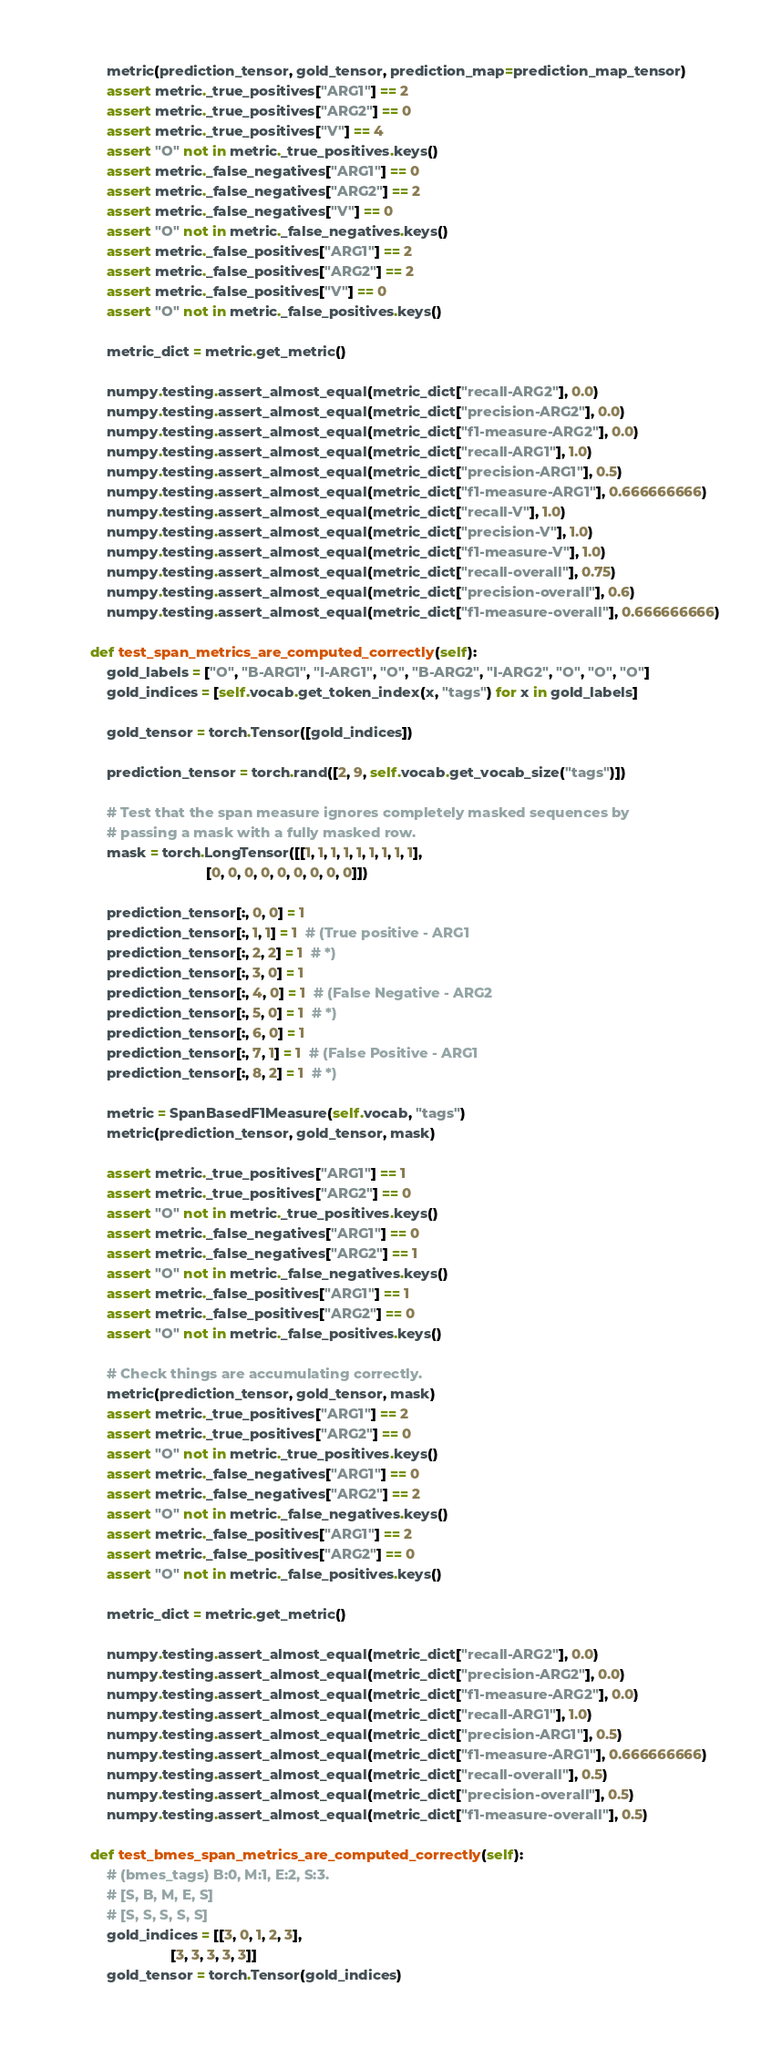Convert code to text. <code><loc_0><loc_0><loc_500><loc_500><_Python_>        metric(prediction_tensor, gold_tensor, prediction_map=prediction_map_tensor)
        assert metric._true_positives["ARG1"] == 2
        assert metric._true_positives["ARG2"] == 0
        assert metric._true_positives["V"] == 4
        assert "O" not in metric._true_positives.keys()
        assert metric._false_negatives["ARG1"] == 0
        assert metric._false_negatives["ARG2"] == 2
        assert metric._false_negatives["V"] == 0
        assert "O" not in metric._false_negatives.keys()
        assert metric._false_positives["ARG1"] == 2
        assert metric._false_positives["ARG2"] == 2
        assert metric._false_positives["V"] == 0
        assert "O" not in metric._false_positives.keys()

        metric_dict = metric.get_metric()

        numpy.testing.assert_almost_equal(metric_dict["recall-ARG2"], 0.0)
        numpy.testing.assert_almost_equal(metric_dict["precision-ARG2"], 0.0)
        numpy.testing.assert_almost_equal(metric_dict["f1-measure-ARG2"], 0.0)
        numpy.testing.assert_almost_equal(metric_dict["recall-ARG1"], 1.0)
        numpy.testing.assert_almost_equal(metric_dict["precision-ARG1"], 0.5)
        numpy.testing.assert_almost_equal(metric_dict["f1-measure-ARG1"], 0.666666666)
        numpy.testing.assert_almost_equal(metric_dict["recall-V"], 1.0)
        numpy.testing.assert_almost_equal(metric_dict["precision-V"], 1.0)
        numpy.testing.assert_almost_equal(metric_dict["f1-measure-V"], 1.0)
        numpy.testing.assert_almost_equal(metric_dict["recall-overall"], 0.75)
        numpy.testing.assert_almost_equal(metric_dict["precision-overall"], 0.6)
        numpy.testing.assert_almost_equal(metric_dict["f1-measure-overall"], 0.666666666)

    def test_span_metrics_are_computed_correctly(self):
        gold_labels = ["O", "B-ARG1", "I-ARG1", "O", "B-ARG2", "I-ARG2", "O", "O", "O"]
        gold_indices = [self.vocab.get_token_index(x, "tags") for x in gold_labels]

        gold_tensor = torch.Tensor([gold_indices])

        prediction_tensor = torch.rand([2, 9, self.vocab.get_vocab_size("tags")])

        # Test that the span measure ignores completely masked sequences by
        # passing a mask with a fully masked row.
        mask = torch.LongTensor([[1, 1, 1, 1, 1, 1, 1, 1, 1],
                                 [0, 0, 0, 0, 0, 0, 0, 0, 0]])

        prediction_tensor[:, 0, 0] = 1
        prediction_tensor[:, 1, 1] = 1  # (True positive - ARG1
        prediction_tensor[:, 2, 2] = 1  # *)
        prediction_tensor[:, 3, 0] = 1
        prediction_tensor[:, 4, 0] = 1  # (False Negative - ARG2
        prediction_tensor[:, 5, 0] = 1  # *)
        prediction_tensor[:, 6, 0] = 1
        prediction_tensor[:, 7, 1] = 1  # (False Positive - ARG1
        prediction_tensor[:, 8, 2] = 1  # *)

        metric = SpanBasedF1Measure(self.vocab, "tags")
        metric(prediction_tensor, gold_tensor, mask)

        assert metric._true_positives["ARG1"] == 1
        assert metric._true_positives["ARG2"] == 0
        assert "O" not in metric._true_positives.keys()
        assert metric._false_negatives["ARG1"] == 0
        assert metric._false_negatives["ARG2"] == 1
        assert "O" not in metric._false_negatives.keys()
        assert metric._false_positives["ARG1"] == 1
        assert metric._false_positives["ARG2"] == 0
        assert "O" not in metric._false_positives.keys()

        # Check things are accumulating correctly.
        metric(prediction_tensor, gold_tensor, mask)
        assert metric._true_positives["ARG1"] == 2
        assert metric._true_positives["ARG2"] == 0
        assert "O" not in metric._true_positives.keys()
        assert metric._false_negatives["ARG1"] == 0
        assert metric._false_negatives["ARG2"] == 2
        assert "O" not in metric._false_negatives.keys()
        assert metric._false_positives["ARG1"] == 2
        assert metric._false_positives["ARG2"] == 0
        assert "O" not in metric._false_positives.keys()

        metric_dict = metric.get_metric()

        numpy.testing.assert_almost_equal(metric_dict["recall-ARG2"], 0.0)
        numpy.testing.assert_almost_equal(metric_dict["precision-ARG2"], 0.0)
        numpy.testing.assert_almost_equal(metric_dict["f1-measure-ARG2"], 0.0)
        numpy.testing.assert_almost_equal(metric_dict["recall-ARG1"], 1.0)
        numpy.testing.assert_almost_equal(metric_dict["precision-ARG1"], 0.5)
        numpy.testing.assert_almost_equal(metric_dict["f1-measure-ARG1"], 0.666666666)
        numpy.testing.assert_almost_equal(metric_dict["recall-overall"], 0.5)
        numpy.testing.assert_almost_equal(metric_dict["precision-overall"], 0.5)
        numpy.testing.assert_almost_equal(metric_dict["f1-measure-overall"], 0.5)

    def test_bmes_span_metrics_are_computed_correctly(self):
        # (bmes_tags) B:0, M:1, E:2, S:3.
        # [S, B, M, E, S]
        # [S, S, S, S, S]
        gold_indices = [[3, 0, 1, 2, 3],
                        [3, 3, 3, 3, 3]]
        gold_tensor = torch.Tensor(gold_indices)
</code> 